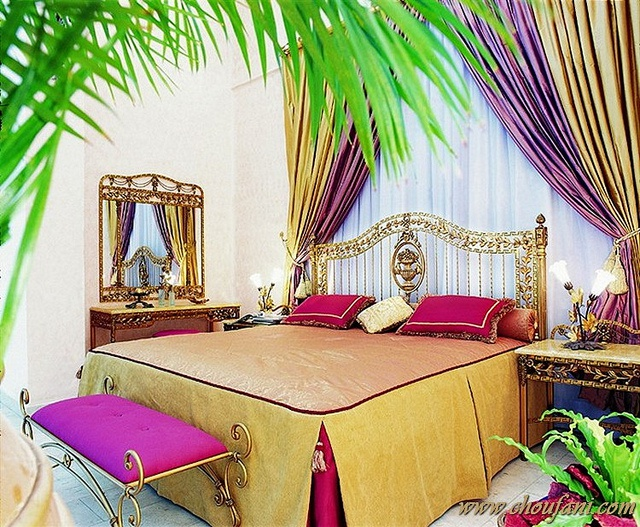Describe the objects in this image and their specific colors. I can see bed in green, tan, and lightgray tones, potted plant in green, beige, and darkgreen tones, and potted plant in green, black, lime, and lightgreen tones in this image. 